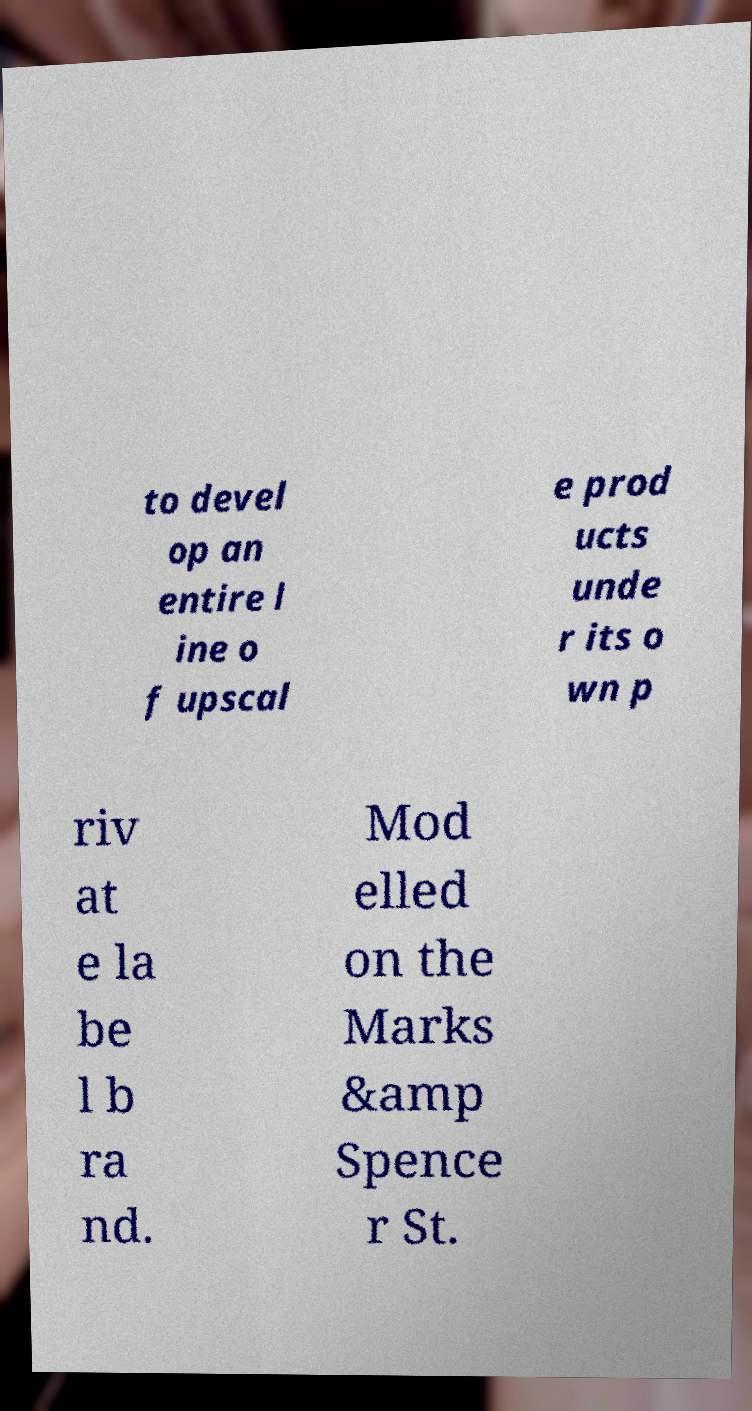Can you accurately transcribe the text from the provided image for me? to devel op an entire l ine o f upscal e prod ucts unde r its o wn p riv at e la be l b ra nd. Mod elled on the Marks &amp Spence r St. 